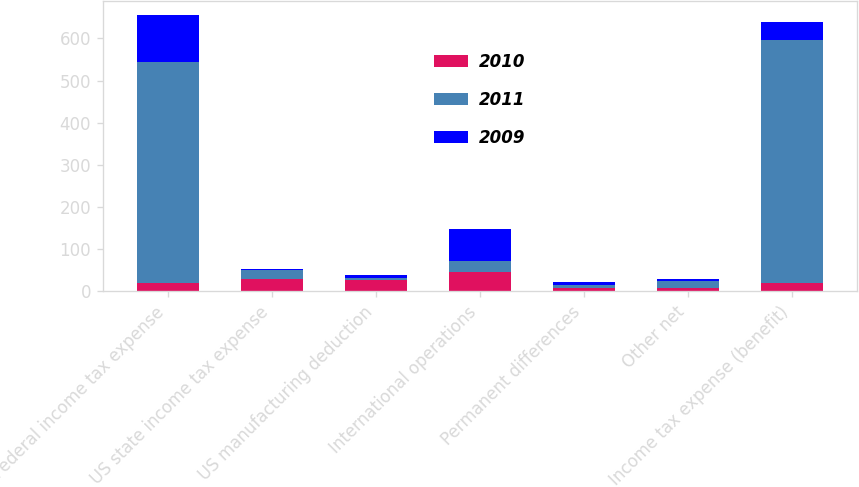<chart> <loc_0><loc_0><loc_500><loc_500><stacked_bar_chart><ecel><fcel>Federal income tax expense<fcel>US state income tax expense<fcel>US manufacturing deduction<fcel>International operations<fcel>Permanent differences<fcel>Other net<fcel>Income tax expense (benefit)<nl><fcel>2010<fcel>21<fcel>29<fcel>28<fcel>46<fcel>8<fcel>8<fcel>21<nl><fcel>2011<fcel>524<fcel>21<fcel>5<fcel>27<fcel>8<fcel>16<fcel>575<nl><fcel>2009<fcel>111<fcel>2<fcel>7<fcel>75<fcel>7<fcel>5<fcel>43<nl></chart> 